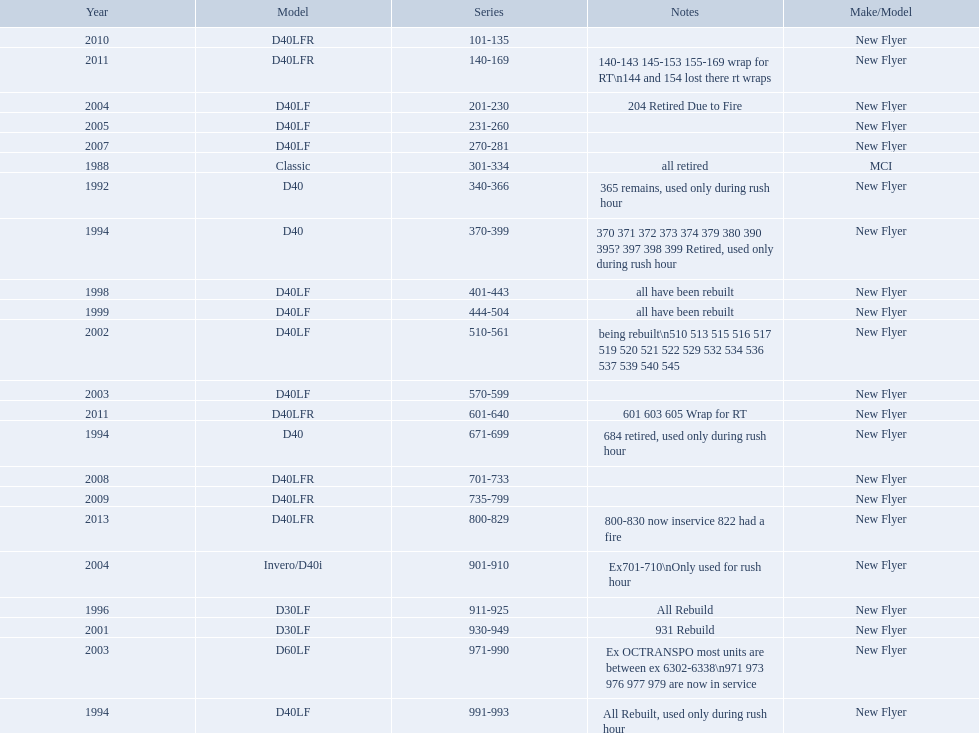What are all the models of buses? D40LFR, D40LF, Classic, D40, Invero/D40i, D30LF, D60LF. Of these buses, which series is the oldest? 301-334. Which is the  newest? 800-829. 